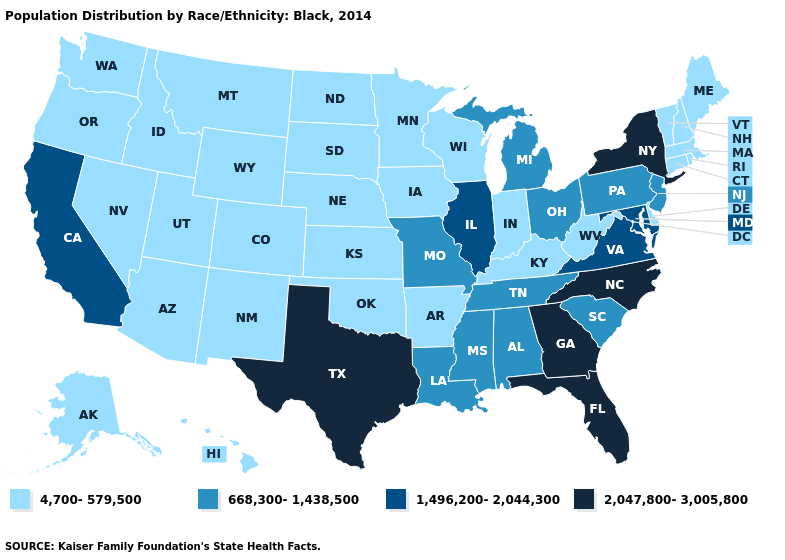What is the lowest value in states that border Montana?
Quick response, please. 4,700-579,500. Name the states that have a value in the range 4,700-579,500?
Concise answer only. Alaska, Arizona, Arkansas, Colorado, Connecticut, Delaware, Hawaii, Idaho, Indiana, Iowa, Kansas, Kentucky, Maine, Massachusetts, Minnesota, Montana, Nebraska, Nevada, New Hampshire, New Mexico, North Dakota, Oklahoma, Oregon, Rhode Island, South Dakota, Utah, Vermont, Washington, West Virginia, Wisconsin, Wyoming. Name the states that have a value in the range 2,047,800-3,005,800?
Be succinct. Florida, Georgia, New York, North Carolina, Texas. How many symbols are there in the legend?
Concise answer only. 4. Does Vermont have a lower value than Colorado?
Concise answer only. No. Name the states that have a value in the range 2,047,800-3,005,800?
Be succinct. Florida, Georgia, New York, North Carolina, Texas. Does California have the lowest value in the West?
Write a very short answer. No. What is the lowest value in states that border New Mexico?
Answer briefly. 4,700-579,500. Does Illinois have a higher value than New York?
Concise answer only. No. What is the value of North Carolina?
Short answer required. 2,047,800-3,005,800. What is the value of Utah?
Concise answer only. 4,700-579,500. What is the value of Maine?
Answer briefly. 4,700-579,500. Is the legend a continuous bar?
Concise answer only. No. Among the states that border Colorado , which have the lowest value?
Answer briefly. Arizona, Kansas, Nebraska, New Mexico, Oklahoma, Utah, Wyoming. Name the states that have a value in the range 2,047,800-3,005,800?
Give a very brief answer. Florida, Georgia, New York, North Carolina, Texas. 